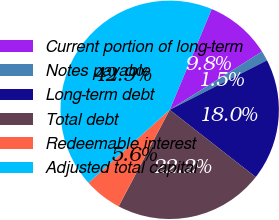Convert chart to OTSL. <chart><loc_0><loc_0><loc_500><loc_500><pie_chart><fcel>Current portion of long-term<fcel>Notes payable<fcel>Long-term debt<fcel>Total debt<fcel>Redeemable interest<fcel>Adjusted total capital<nl><fcel>9.76%<fcel>1.47%<fcel>18.04%<fcel>22.19%<fcel>5.61%<fcel>42.93%<nl></chart> 